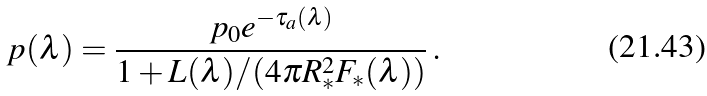<formula> <loc_0><loc_0><loc_500><loc_500>p ( \lambda ) = \frac { p _ { 0 } e ^ { - \tau _ { a } ( \lambda ) } } { 1 + L ( \lambda ) / ( 4 \pi R _ { * } ^ { 2 } F _ { * } ( \lambda ) ) } \, .</formula> 